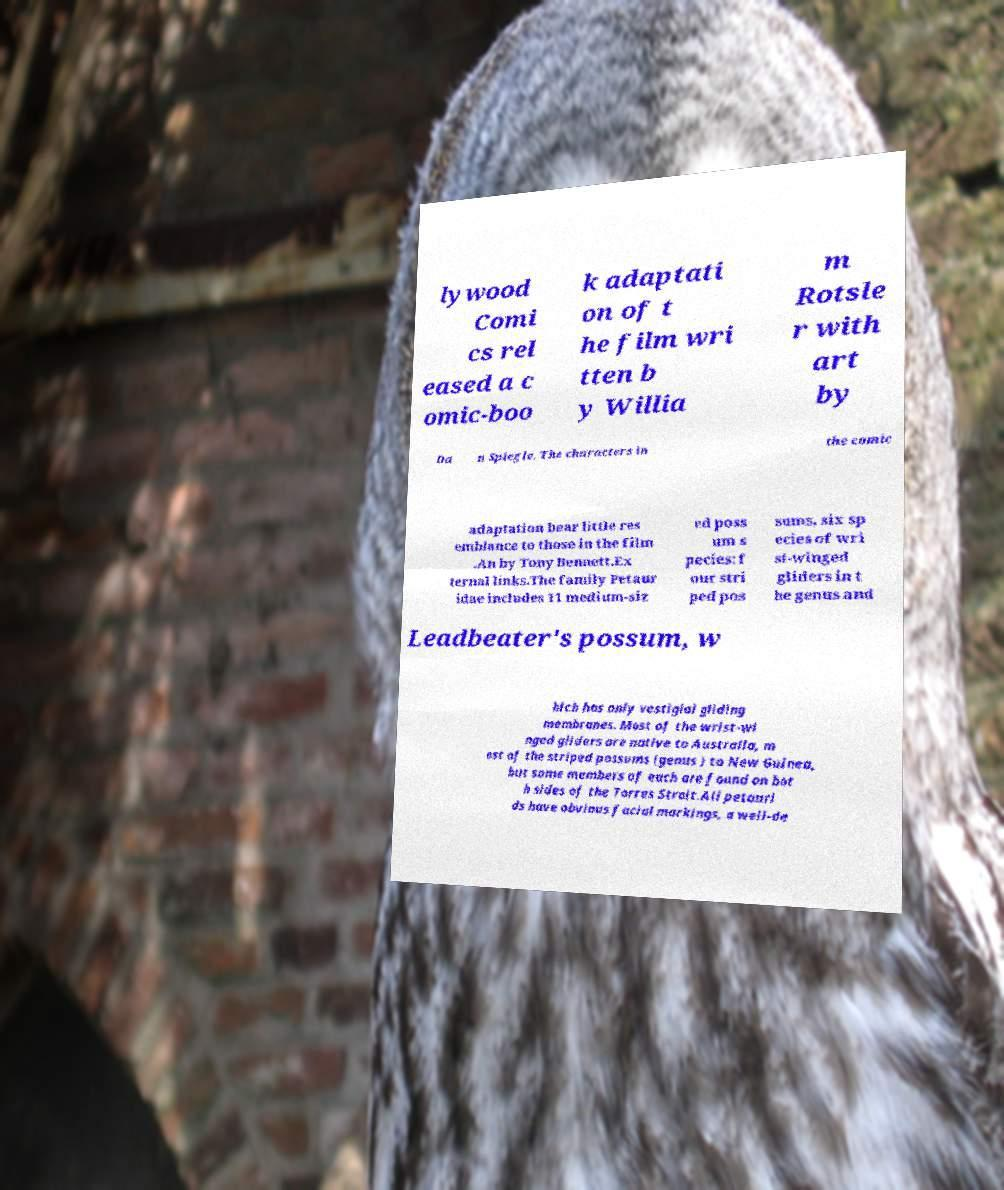There's text embedded in this image that I need extracted. Can you transcribe it verbatim? lywood Comi cs rel eased a c omic-boo k adaptati on of t he film wri tten b y Willia m Rotsle r with art by Da n Spiegle. The characters in the comic adaptation bear little res emblance to those in the film .An by Tony Bennett.Ex ternal links.The family Petaur idae includes 11 medium-siz ed poss um s pecies: f our stri ped pos sums, six sp ecies of wri st-winged gliders in t he genus and Leadbeater's possum, w hich has only vestigial gliding membranes. Most of the wrist-wi nged gliders are native to Australia, m ost of the striped possums (genus ) to New Guinea, but some members of each are found on bot h sides of the Torres Strait.All petauri ds have obvious facial markings, a well-de 